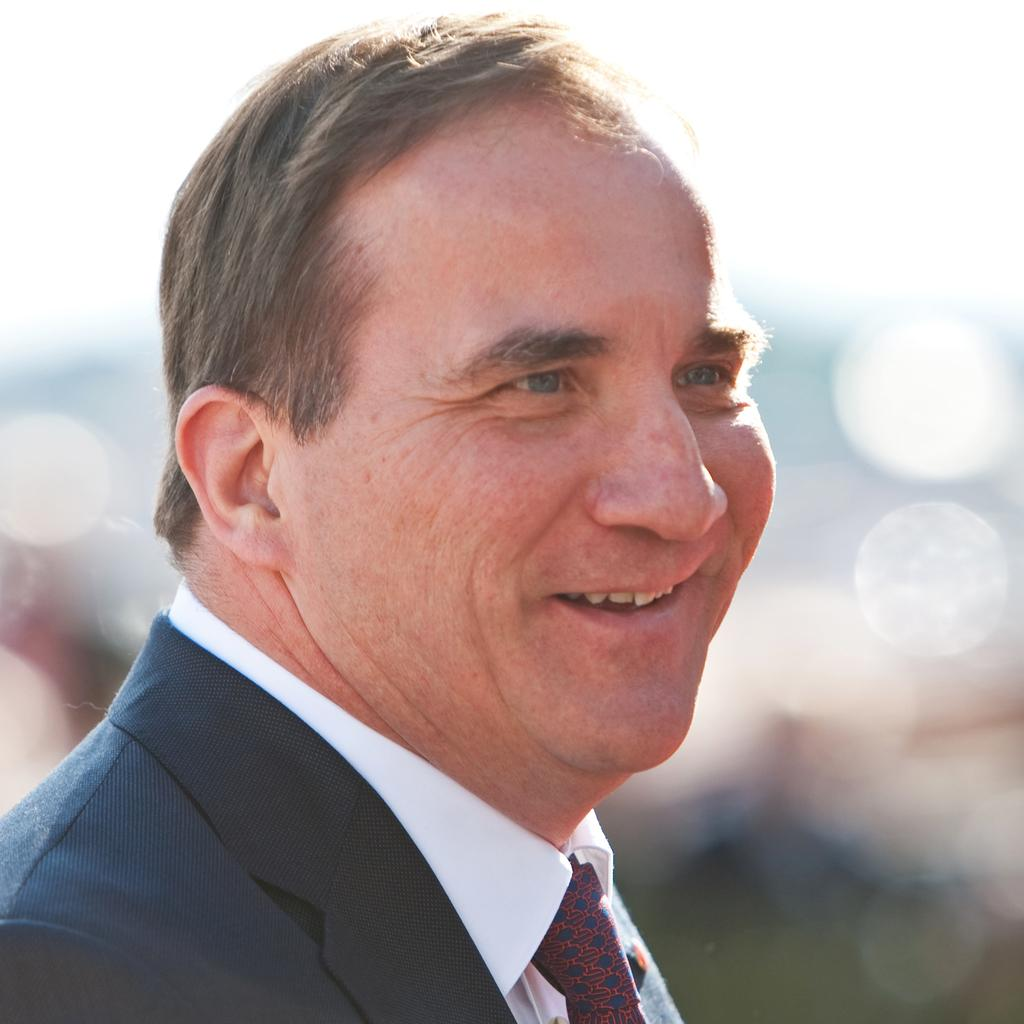What is present in the image? There is a person in the image. What is the person wearing? The person is wearing a blazer. What is the person's facial expression? The person is smiling. What type of skirt is the person wearing in the image? There is no skirt present in the image; the person is wearing a blazer. 